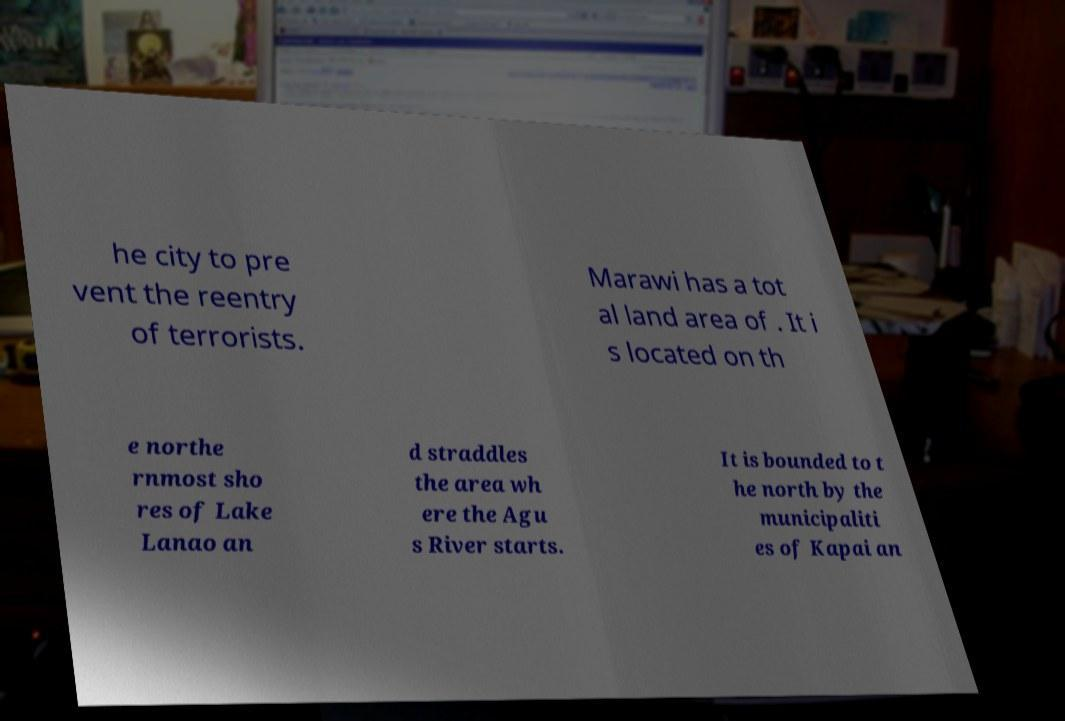For documentation purposes, I need the text within this image transcribed. Could you provide that? he city to pre vent the reentry of terrorists. Marawi has a tot al land area of . It i s located on th e northe rnmost sho res of Lake Lanao an d straddles the area wh ere the Agu s River starts. It is bounded to t he north by the municipaliti es of Kapai an 